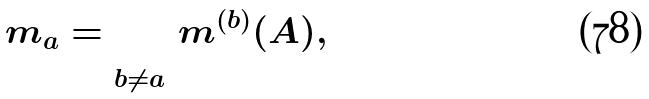Convert formula to latex. <formula><loc_0><loc_0><loc_500><loc_500>m _ { a } = \sum _ { b \neq a } m ^ { ( b ) } ( A ) ,</formula> 